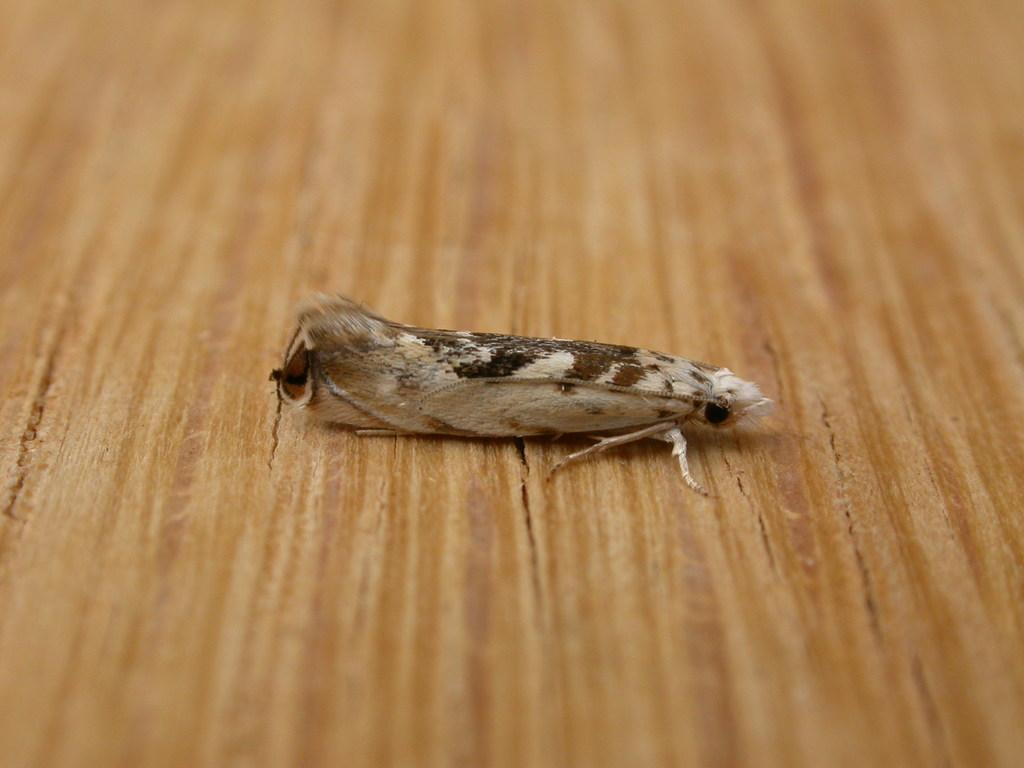What piece of furniture is present in the image? There is a table in the image. What type of living organism can be seen on the table? There is an insect on the table. What type of nail is being used to climb the mountain in the image? There is no mountain or nail present in the image; it only features a table and an insect. 